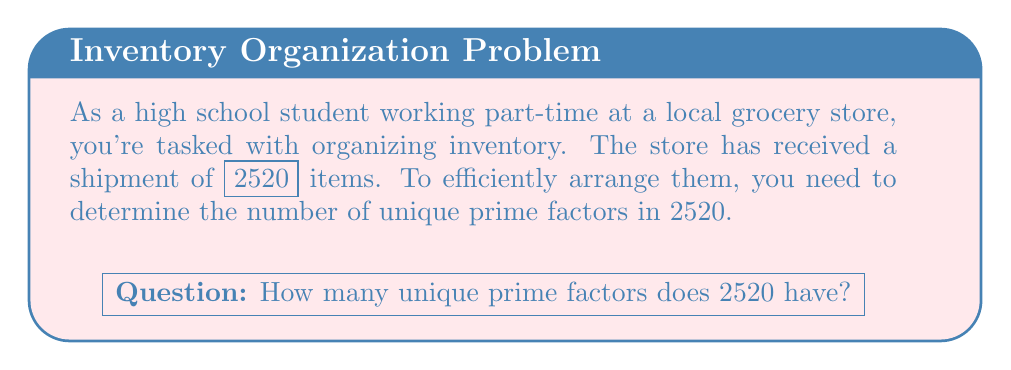Teach me how to tackle this problem. Let's approach this step-by-step:

1) First, we need to find the prime factorization of 2520.

2) To do this, let's divide 2520 by the smallest prime number that divides it evenly, starting with 2:

   $2520 = 2 \times 1260$
   $1260 = 2 \times 630$
   $630 = 2 \times 315$
   $315 = 3 \times 105$
   $105 = 3 \times 35$
   $35 = 5 \times 7$

3) Now we can write the prime factorization:

   $2520 = 2^3 \times 3^2 \times 5 \times 7$

4) To find the number of unique prime factors, we simply count the number of different prime numbers in this factorization.

5) The unique prime factors are 2, 3, 5, and 7.

Therefore, 2520 has 4 unique prime factors.
Answer: 4 